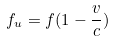<formula> <loc_0><loc_0><loc_500><loc_500>f _ { u } = f ( 1 - \frac { v } { c } )</formula> 